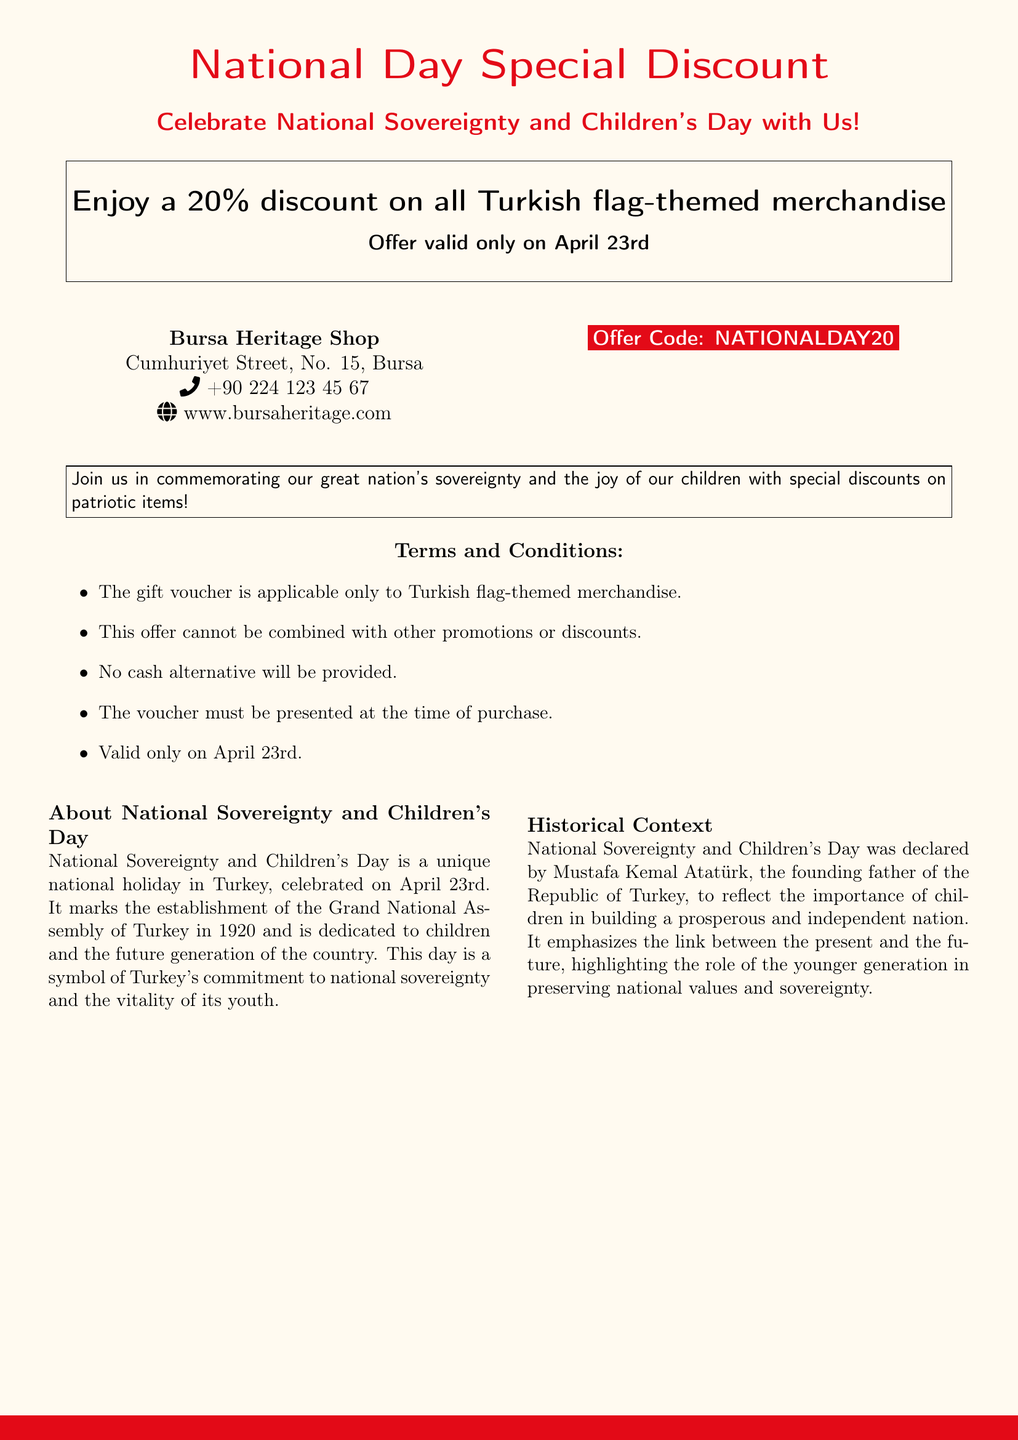What is the discount percentage? The voucher offers a 20% discount on all Turkish flag-themed merchandise.
Answer: 20% When is the voucher valid? The offer is valid only on April 23rd, the National Sovereignty and Children's Day.
Answer: April 23rd What is the offer code? The document provides an offer code for the discount which is "NATIONALDAY20".
Answer: NATIONALDAY20 Where is the Bursa Heritage Shop located? The address is Cumhuriyet Street, No. 15, Bursa.
Answer: Cumhuriyet Street, No. 15, Bursa Who declared National Sovereignty and Children's Day? The day was declared by Mustafa Kemal Atatürk, the founding father of the Republic of Turkey.
Answer: Mustafa Kemal Atatürk What type of merchandise does the voucher apply to? The voucher is applicable only to Turkish flag-themed merchandise.
Answer: Turkish flag-themed merchandise What should be presented at the time of purchase? The voucher must be presented when making a purchase to apply the discount.
Answer: The voucher What is the significance of April 23rd? It marks the establishment of the Grand National Assembly of Turkey in 1920.
Answer: Establishment of the Grand National Assembly in 1920 Is the voucher combinable with other promotions? The offer cannot be combined with other promotions or discounts according to the terms.
Answer: No 